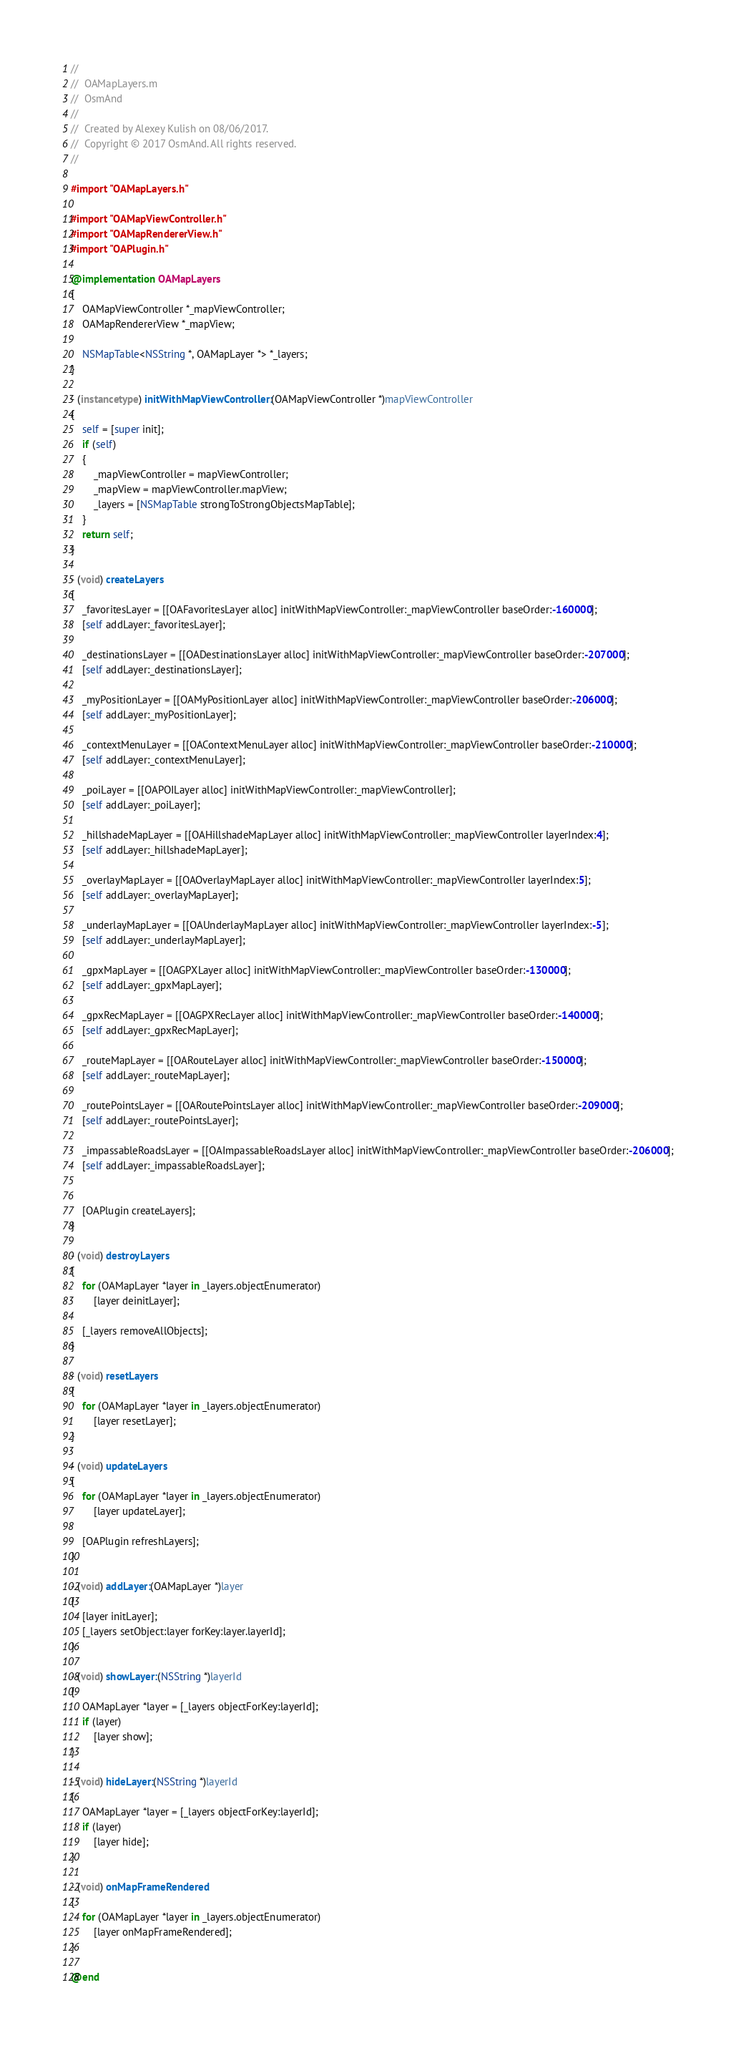<code> <loc_0><loc_0><loc_500><loc_500><_ObjectiveC_>//
//  OAMapLayers.m
//  OsmAnd
//
//  Created by Alexey Kulish on 08/06/2017.
//  Copyright © 2017 OsmAnd. All rights reserved.
//

#import "OAMapLayers.h"

#import "OAMapViewController.h"
#import "OAMapRendererView.h"
#import "OAPlugin.h"

@implementation OAMapLayers
{
    OAMapViewController *_mapViewController;
    OAMapRendererView *_mapView;
    
    NSMapTable<NSString *, OAMapLayer *> *_layers;
}

- (instancetype) initWithMapViewController:(OAMapViewController *)mapViewController
{
    self = [super init];
    if (self)
    {
        _mapViewController = mapViewController;
        _mapView = mapViewController.mapView;
        _layers = [NSMapTable strongToStrongObjectsMapTable];
    }
    return self;
}

- (void) createLayers
{
    _favoritesLayer = [[OAFavoritesLayer alloc] initWithMapViewController:_mapViewController baseOrder:-160000];
    [self addLayer:_favoritesLayer];

    _destinationsLayer = [[OADestinationsLayer alloc] initWithMapViewController:_mapViewController baseOrder:-207000];
    [self addLayer:_destinationsLayer];

    _myPositionLayer = [[OAMyPositionLayer alloc] initWithMapViewController:_mapViewController baseOrder:-206000];
    [self addLayer:_myPositionLayer];

    _contextMenuLayer = [[OAContextMenuLayer alloc] initWithMapViewController:_mapViewController baseOrder:-210000];
    [self addLayer:_contextMenuLayer];

    _poiLayer = [[OAPOILayer alloc] initWithMapViewController:_mapViewController];
    [self addLayer:_poiLayer];

    _hillshadeMapLayer = [[OAHillshadeMapLayer alloc] initWithMapViewController:_mapViewController layerIndex:4];
    [self addLayer:_hillshadeMapLayer];
    
    _overlayMapLayer = [[OAOverlayMapLayer alloc] initWithMapViewController:_mapViewController layerIndex:5];
    [self addLayer:_overlayMapLayer];

    _underlayMapLayer = [[OAUnderlayMapLayer alloc] initWithMapViewController:_mapViewController layerIndex:-5];
    [self addLayer:_underlayMapLayer];

    _gpxMapLayer = [[OAGPXLayer alloc] initWithMapViewController:_mapViewController baseOrder:-130000];
    [self addLayer:_gpxMapLayer];

    _gpxRecMapLayer = [[OAGPXRecLayer alloc] initWithMapViewController:_mapViewController baseOrder:-140000];
    [self addLayer:_gpxRecMapLayer];

    _routeMapLayer = [[OARouteLayer alloc] initWithMapViewController:_mapViewController baseOrder:-150000];
    [self addLayer:_routeMapLayer];

    _routePointsLayer = [[OARoutePointsLayer alloc] initWithMapViewController:_mapViewController baseOrder:-209000];
    [self addLayer:_routePointsLayer];
    
    _impassableRoadsLayer = [[OAImpassableRoadsLayer alloc] initWithMapViewController:_mapViewController baseOrder:-206000];
    [self addLayer:_impassableRoadsLayer];
    
    
    [OAPlugin createLayers];
}

- (void) destroyLayers
{
    for (OAMapLayer *layer in _layers.objectEnumerator)
        [layer deinitLayer];

    [_layers removeAllObjects];
}

- (void) resetLayers
{
    for (OAMapLayer *layer in _layers.objectEnumerator)
        [layer resetLayer];
}

- (void) updateLayers
{
    for (OAMapLayer *layer in _layers.objectEnumerator)
        [layer updateLayer];
    
    [OAPlugin refreshLayers];
}

- (void) addLayer:(OAMapLayer *)layer
{
    [layer initLayer];
    [_layers setObject:layer forKey:layer.layerId];
}

- (void) showLayer:(NSString *)layerId
{
    OAMapLayer *layer = [_layers objectForKey:layerId];
    if (layer)
        [layer show];
}

- (void) hideLayer:(NSString *)layerId
{
    OAMapLayer *layer = [_layers objectForKey:layerId];
    if (layer)
        [layer hide];
}

- (void) onMapFrameRendered
{
    for (OAMapLayer *layer in _layers.objectEnumerator)
        [layer onMapFrameRendered];
}

@end
</code> 